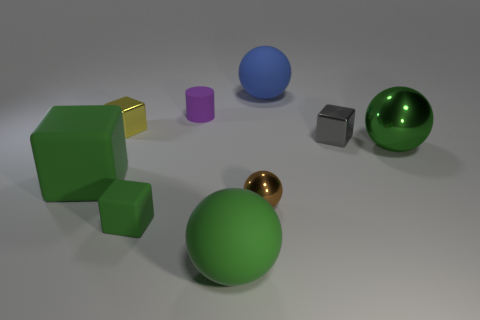What is the material of the tiny purple cylinder? While I can't determine the material with absolute certainty from just an image, the tiny purple cylinder appears to be made of a matte plastic based on its visual texture and the way light is diffusely reflecting off its surface. 